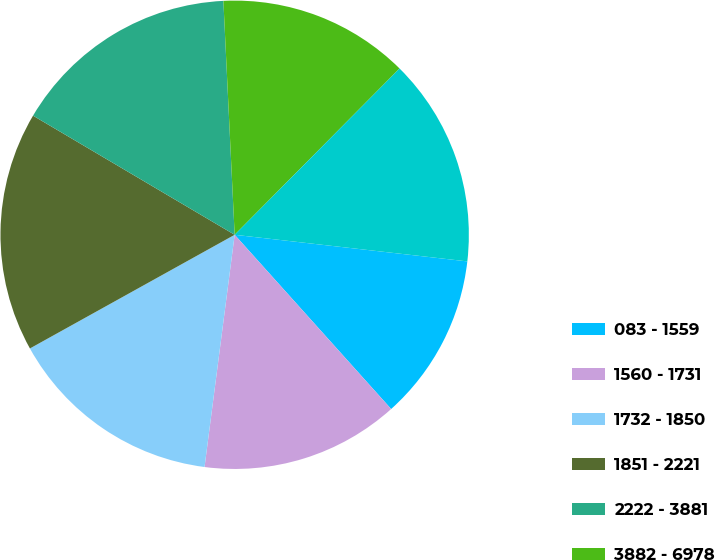Convert chart. <chart><loc_0><loc_0><loc_500><loc_500><pie_chart><fcel>083 - 1559<fcel>1560 - 1731<fcel>1732 - 1850<fcel>1851 - 2221<fcel>2222 - 3881<fcel>3882 - 6978<fcel>083 - 6978<nl><fcel>11.54%<fcel>13.7%<fcel>14.88%<fcel>16.56%<fcel>15.74%<fcel>13.2%<fcel>14.38%<nl></chart> 